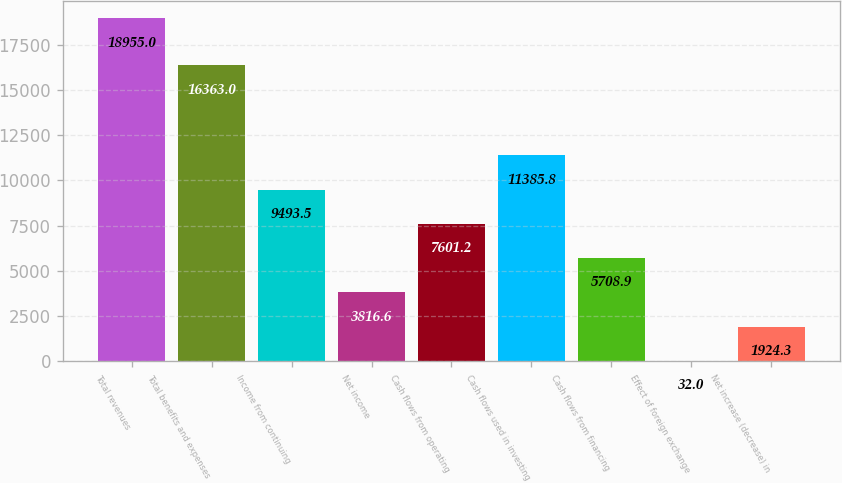<chart> <loc_0><loc_0><loc_500><loc_500><bar_chart><fcel>Total revenues<fcel>Total benefits and expenses<fcel>Income from continuing<fcel>Net income<fcel>Cash flows from operating<fcel>Cash flows used in investing<fcel>Cash flows from financing<fcel>Effect of foreign exchange<fcel>Net increase (decrease) in<nl><fcel>18955<fcel>16363<fcel>9493.5<fcel>3816.6<fcel>7601.2<fcel>11385.8<fcel>5708.9<fcel>32<fcel>1924.3<nl></chart> 